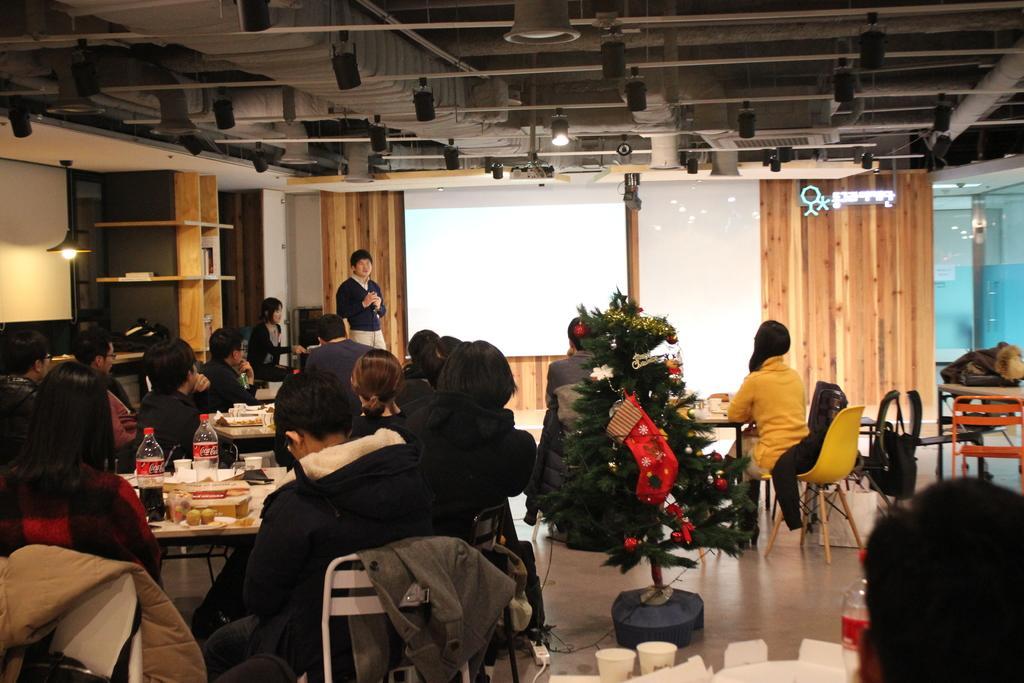How would you summarize this image in a sentence or two? It looks like a party ,there are many tables and food on the tables,around the table some people are sitting,in the middle of the room there is a tree decorated in the background a man is standing ,to his right side there is white board ,behind it is there is a wooden wall. 